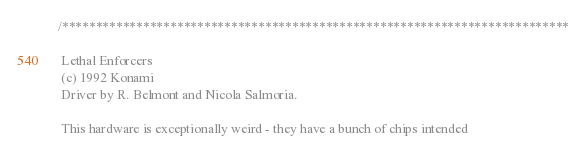Convert code to text. <code><loc_0><loc_0><loc_500><loc_500><_C_>/***************************************************************************

 Lethal Enforcers
 (c) 1992 Konami
 Driver by R. Belmont and Nicola Salmoria.

 This hardware is exceptionally weird - they have a bunch of chips intended</code> 